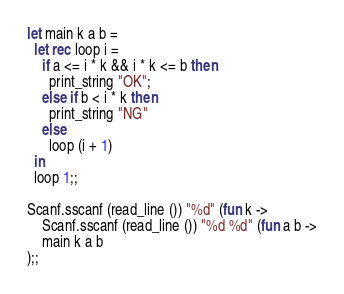<code> <loc_0><loc_0><loc_500><loc_500><_OCaml_>let main k a b =
  let rec loop i =
    if a <= i * k && i * k <= b then
      print_string "OK";
    else if b < i * k then
      print_string "NG"
    else
      loop (i + 1)
  in
  loop 1;;

Scanf.sscanf (read_line ()) "%d" (fun k ->
    Scanf.sscanf (read_line ()) "%d %d" (fun a b ->
	main k a b
);;</code> 